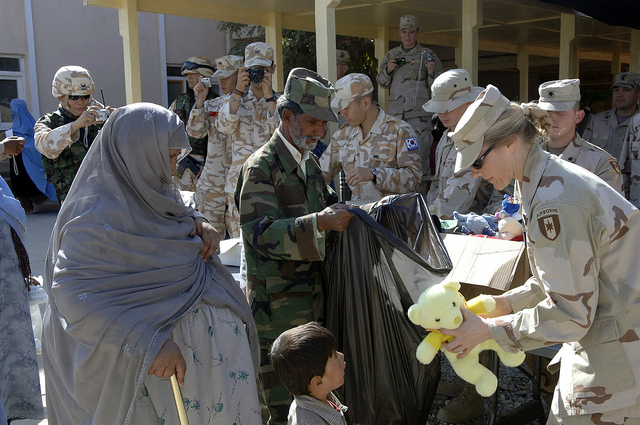What are some possible emotions of the individuals in this scene? The individuals in this scene are likely experiencing a mix of emotions. The soldiers might be feeling a sense of duty, dedication, and compassion as they distribute aid to the civilians. They may also feel camaraderie and teamwork, given the collaborative nature of the event. The local civilians, on the other hand, might be experiencing feelings of hope, relief, and gratitude as they receive the necessary supplies and toys for their children. The children, especially, are likely feeling joy, excitement, and comfort upon receiving toys like the teddy bear, which represents a rare moment of normalcy and happiness in their lives. Can you imagine a future scene influenced by this event? Fast forward several years, the initial compassion shown during this humanitarian event has blossomed into a robust partnership between the military forces and the local community. The soldiers regularly visit to provide not only supplies but also educational programs, healthcare, and infrastructural support. The young boy who received the teddy bear is now a teenager, inspired by the soldiers' kindness. He volunteers at the community center, helping to distribute goods and teaching younger children. The seeds of hope and trust planted during that initial event have grown into a harmonious relationship that continuously nurtures the community’s growth and resilience. 